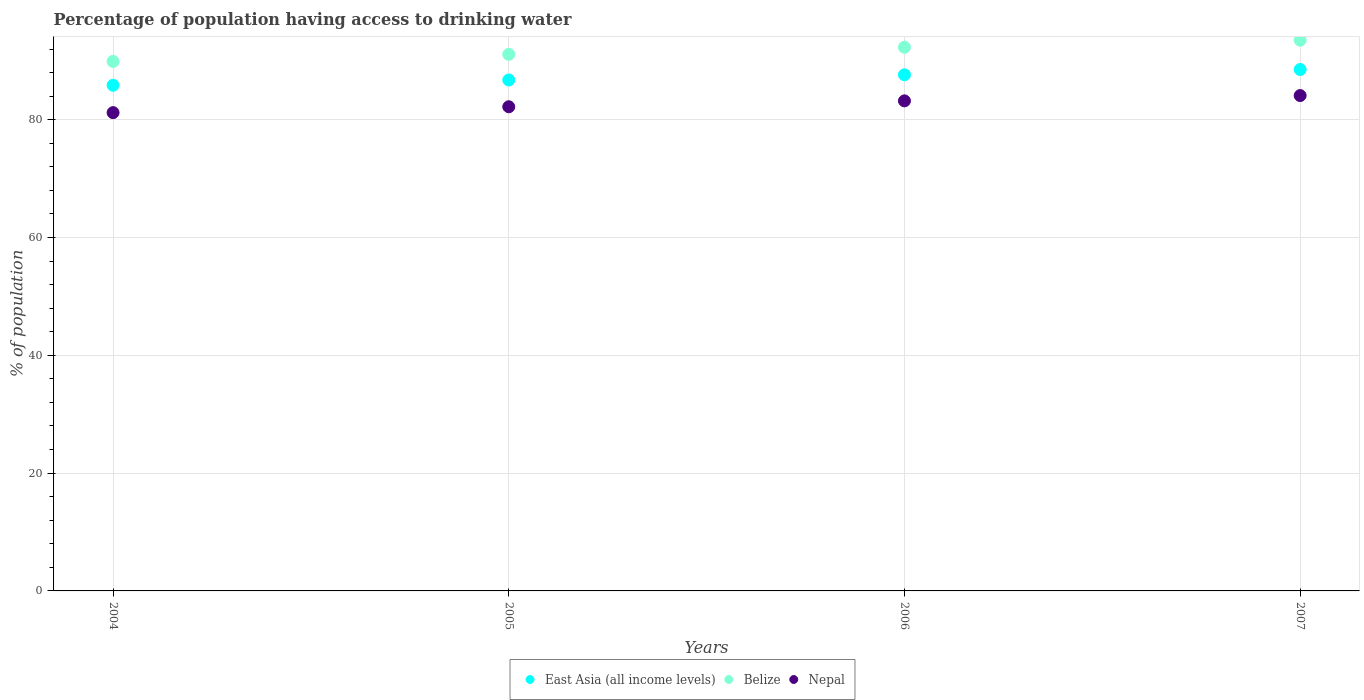How many different coloured dotlines are there?
Your response must be concise. 3. Is the number of dotlines equal to the number of legend labels?
Your answer should be compact. Yes. What is the percentage of population having access to drinking water in Belize in 2005?
Your response must be concise. 91.1. Across all years, what is the maximum percentage of population having access to drinking water in East Asia (all income levels)?
Your answer should be compact. 88.52. Across all years, what is the minimum percentage of population having access to drinking water in East Asia (all income levels)?
Ensure brevity in your answer.  85.85. In which year was the percentage of population having access to drinking water in East Asia (all income levels) maximum?
Offer a terse response. 2007. What is the total percentage of population having access to drinking water in Belize in the graph?
Offer a very short reply. 366.8. What is the difference between the percentage of population having access to drinking water in East Asia (all income levels) in 2004 and that in 2005?
Your response must be concise. -0.89. What is the difference between the percentage of population having access to drinking water in Belize in 2006 and the percentage of population having access to drinking water in East Asia (all income levels) in 2005?
Provide a short and direct response. 5.56. What is the average percentage of population having access to drinking water in East Asia (all income levels) per year?
Offer a terse response. 87.19. In the year 2007, what is the difference between the percentage of population having access to drinking water in Belize and percentage of population having access to drinking water in Nepal?
Your response must be concise. 9.4. What is the ratio of the percentage of population having access to drinking water in Nepal in 2004 to that in 2005?
Offer a very short reply. 0.99. Is the percentage of population having access to drinking water in Belize in 2004 less than that in 2005?
Give a very brief answer. Yes. Is the difference between the percentage of population having access to drinking water in Belize in 2006 and 2007 greater than the difference between the percentage of population having access to drinking water in Nepal in 2006 and 2007?
Keep it short and to the point. No. What is the difference between the highest and the second highest percentage of population having access to drinking water in Belize?
Your response must be concise. 1.2. What is the difference between the highest and the lowest percentage of population having access to drinking water in Nepal?
Provide a short and direct response. 2.9. Is the percentage of population having access to drinking water in Belize strictly greater than the percentage of population having access to drinking water in East Asia (all income levels) over the years?
Make the answer very short. Yes. How many dotlines are there?
Make the answer very short. 3. Does the graph contain any zero values?
Your response must be concise. No. How many legend labels are there?
Make the answer very short. 3. What is the title of the graph?
Offer a very short reply. Percentage of population having access to drinking water. Does "Timor-Leste" appear as one of the legend labels in the graph?
Provide a succinct answer. No. What is the label or title of the X-axis?
Your response must be concise. Years. What is the label or title of the Y-axis?
Your response must be concise. % of population. What is the % of population of East Asia (all income levels) in 2004?
Provide a succinct answer. 85.85. What is the % of population in Belize in 2004?
Make the answer very short. 89.9. What is the % of population in Nepal in 2004?
Provide a short and direct response. 81.2. What is the % of population in East Asia (all income levels) in 2005?
Your answer should be very brief. 86.74. What is the % of population of Belize in 2005?
Offer a very short reply. 91.1. What is the % of population of Nepal in 2005?
Provide a short and direct response. 82.2. What is the % of population in East Asia (all income levels) in 2006?
Your response must be concise. 87.63. What is the % of population of Belize in 2006?
Keep it short and to the point. 92.3. What is the % of population of Nepal in 2006?
Give a very brief answer. 83.2. What is the % of population in East Asia (all income levels) in 2007?
Your response must be concise. 88.52. What is the % of population in Belize in 2007?
Your answer should be compact. 93.5. What is the % of population in Nepal in 2007?
Your response must be concise. 84.1. Across all years, what is the maximum % of population of East Asia (all income levels)?
Your answer should be very brief. 88.52. Across all years, what is the maximum % of population of Belize?
Keep it short and to the point. 93.5. Across all years, what is the maximum % of population of Nepal?
Offer a terse response. 84.1. Across all years, what is the minimum % of population of East Asia (all income levels)?
Provide a succinct answer. 85.85. Across all years, what is the minimum % of population of Belize?
Ensure brevity in your answer.  89.9. Across all years, what is the minimum % of population of Nepal?
Your answer should be very brief. 81.2. What is the total % of population in East Asia (all income levels) in the graph?
Provide a succinct answer. 348.75. What is the total % of population in Belize in the graph?
Offer a very short reply. 366.8. What is the total % of population in Nepal in the graph?
Your response must be concise. 330.7. What is the difference between the % of population in East Asia (all income levels) in 2004 and that in 2005?
Ensure brevity in your answer.  -0.89. What is the difference between the % of population of Belize in 2004 and that in 2005?
Make the answer very short. -1.2. What is the difference between the % of population of East Asia (all income levels) in 2004 and that in 2006?
Give a very brief answer. -1.78. What is the difference between the % of population in Nepal in 2004 and that in 2006?
Provide a succinct answer. -2. What is the difference between the % of population of East Asia (all income levels) in 2004 and that in 2007?
Ensure brevity in your answer.  -2.67. What is the difference between the % of population of Belize in 2004 and that in 2007?
Ensure brevity in your answer.  -3.6. What is the difference between the % of population in Nepal in 2004 and that in 2007?
Your answer should be very brief. -2.9. What is the difference between the % of population in East Asia (all income levels) in 2005 and that in 2006?
Your answer should be very brief. -0.88. What is the difference between the % of population in Nepal in 2005 and that in 2006?
Your answer should be compact. -1. What is the difference between the % of population of East Asia (all income levels) in 2005 and that in 2007?
Make the answer very short. -1.78. What is the difference between the % of population in Belize in 2005 and that in 2007?
Your response must be concise. -2.4. What is the difference between the % of population in East Asia (all income levels) in 2006 and that in 2007?
Provide a short and direct response. -0.89. What is the difference between the % of population of Nepal in 2006 and that in 2007?
Your answer should be compact. -0.9. What is the difference between the % of population of East Asia (all income levels) in 2004 and the % of population of Belize in 2005?
Offer a terse response. -5.25. What is the difference between the % of population of East Asia (all income levels) in 2004 and the % of population of Nepal in 2005?
Ensure brevity in your answer.  3.65. What is the difference between the % of population of East Asia (all income levels) in 2004 and the % of population of Belize in 2006?
Ensure brevity in your answer.  -6.45. What is the difference between the % of population of East Asia (all income levels) in 2004 and the % of population of Nepal in 2006?
Offer a very short reply. 2.65. What is the difference between the % of population of East Asia (all income levels) in 2004 and the % of population of Belize in 2007?
Make the answer very short. -7.65. What is the difference between the % of population in East Asia (all income levels) in 2004 and the % of population in Nepal in 2007?
Your answer should be very brief. 1.75. What is the difference between the % of population in Belize in 2004 and the % of population in Nepal in 2007?
Your answer should be compact. 5.8. What is the difference between the % of population in East Asia (all income levels) in 2005 and the % of population in Belize in 2006?
Provide a succinct answer. -5.56. What is the difference between the % of population in East Asia (all income levels) in 2005 and the % of population in Nepal in 2006?
Provide a short and direct response. 3.54. What is the difference between the % of population of Belize in 2005 and the % of population of Nepal in 2006?
Your answer should be very brief. 7.9. What is the difference between the % of population in East Asia (all income levels) in 2005 and the % of population in Belize in 2007?
Make the answer very short. -6.76. What is the difference between the % of population in East Asia (all income levels) in 2005 and the % of population in Nepal in 2007?
Offer a terse response. 2.64. What is the difference between the % of population in Belize in 2005 and the % of population in Nepal in 2007?
Provide a succinct answer. 7. What is the difference between the % of population of East Asia (all income levels) in 2006 and the % of population of Belize in 2007?
Your answer should be very brief. -5.87. What is the difference between the % of population in East Asia (all income levels) in 2006 and the % of population in Nepal in 2007?
Your response must be concise. 3.53. What is the difference between the % of population in Belize in 2006 and the % of population in Nepal in 2007?
Your answer should be very brief. 8.2. What is the average % of population in East Asia (all income levels) per year?
Offer a very short reply. 87.19. What is the average % of population in Belize per year?
Your answer should be compact. 91.7. What is the average % of population in Nepal per year?
Ensure brevity in your answer.  82.67. In the year 2004, what is the difference between the % of population in East Asia (all income levels) and % of population in Belize?
Your response must be concise. -4.05. In the year 2004, what is the difference between the % of population of East Asia (all income levels) and % of population of Nepal?
Provide a short and direct response. 4.65. In the year 2004, what is the difference between the % of population in Belize and % of population in Nepal?
Ensure brevity in your answer.  8.7. In the year 2005, what is the difference between the % of population in East Asia (all income levels) and % of population in Belize?
Your response must be concise. -4.36. In the year 2005, what is the difference between the % of population of East Asia (all income levels) and % of population of Nepal?
Provide a short and direct response. 4.54. In the year 2005, what is the difference between the % of population of Belize and % of population of Nepal?
Keep it short and to the point. 8.9. In the year 2006, what is the difference between the % of population in East Asia (all income levels) and % of population in Belize?
Offer a very short reply. -4.67. In the year 2006, what is the difference between the % of population in East Asia (all income levels) and % of population in Nepal?
Make the answer very short. 4.43. In the year 2007, what is the difference between the % of population in East Asia (all income levels) and % of population in Belize?
Ensure brevity in your answer.  -4.98. In the year 2007, what is the difference between the % of population in East Asia (all income levels) and % of population in Nepal?
Offer a very short reply. 4.42. What is the ratio of the % of population in Belize in 2004 to that in 2005?
Your answer should be very brief. 0.99. What is the ratio of the % of population in Nepal in 2004 to that in 2005?
Keep it short and to the point. 0.99. What is the ratio of the % of population of East Asia (all income levels) in 2004 to that in 2006?
Ensure brevity in your answer.  0.98. What is the ratio of the % of population of East Asia (all income levels) in 2004 to that in 2007?
Offer a very short reply. 0.97. What is the ratio of the % of population in Belize in 2004 to that in 2007?
Provide a short and direct response. 0.96. What is the ratio of the % of population of Nepal in 2004 to that in 2007?
Your response must be concise. 0.97. What is the ratio of the % of population in East Asia (all income levels) in 2005 to that in 2006?
Provide a short and direct response. 0.99. What is the ratio of the % of population in Nepal in 2005 to that in 2006?
Your response must be concise. 0.99. What is the ratio of the % of population in East Asia (all income levels) in 2005 to that in 2007?
Your response must be concise. 0.98. What is the ratio of the % of population in Belize in 2005 to that in 2007?
Provide a succinct answer. 0.97. What is the ratio of the % of population in Nepal in 2005 to that in 2007?
Ensure brevity in your answer.  0.98. What is the ratio of the % of population in East Asia (all income levels) in 2006 to that in 2007?
Provide a short and direct response. 0.99. What is the ratio of the % of population of Belize in 2006 to that in 2007?
Ensure brevity in your answer.  0.99. What is the ratio of the % of population in Nepal in 2006 to that in 2007?
Your answer should be very brief. 0.99. What is the difference between the highest and the second highest % of population of East Asia (all income levels)?
Make the answer very short. 0.89. What is the difference between the highest and the second highest % of population in Nepal?
Give a very brief answer. 0.9. What is the difference between the highest and the lowest % of population of East Asia (all income levels)?
Make the answer very short. 2.67. What is the difference between the highest and the lowest % of population in Belize?
Make the answer very short. 3.6. What is the difference between the highest and the lowest % of population of Nepal?
Keep it short and to the point. 2.9. 